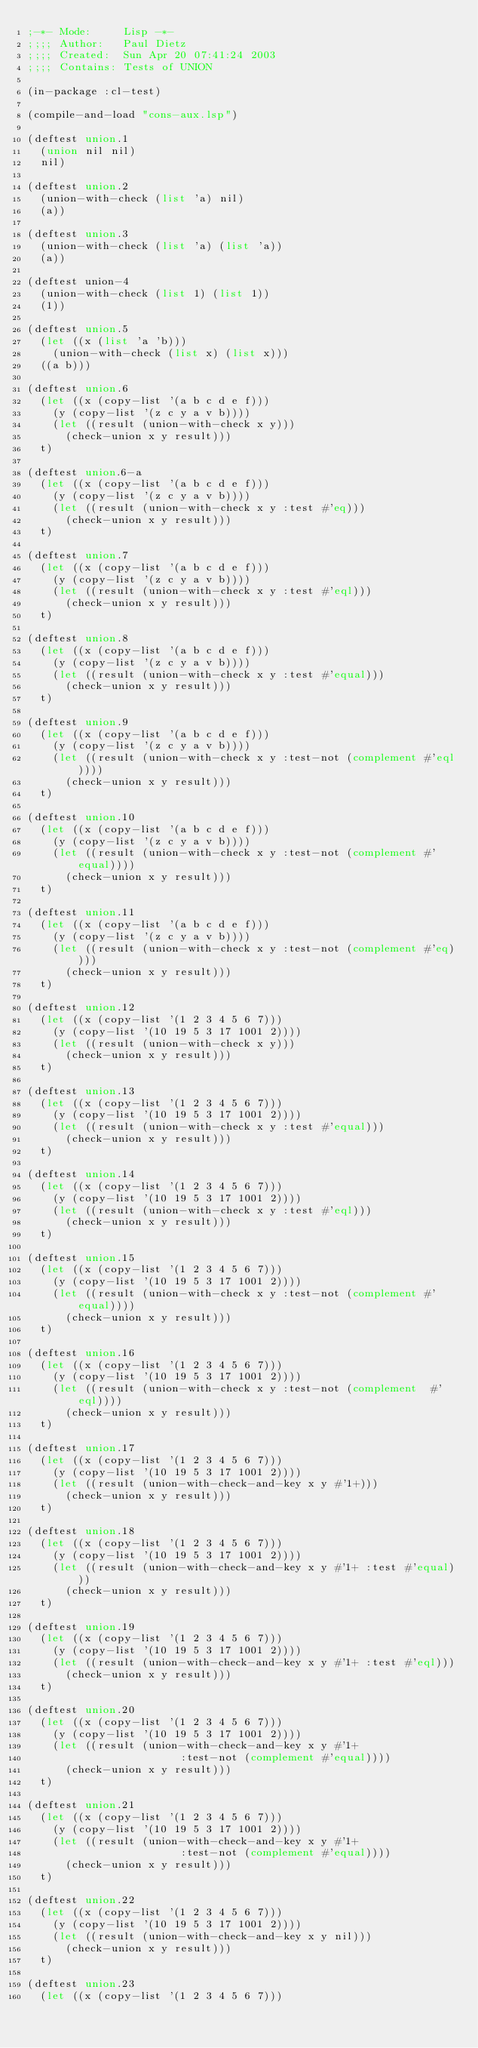Convert code to text. <code><loc_0><loc_0><loc_500><loc_500><_Lisp_>;-*- Mode:     Lisp -*-
;;;; Author:   Paul Dietz
;;;; Created:  Sun Apr 20 07:41:24 2003
;;;; Contains: Tests of UNION

(in-package :cl-test)

(compile-and-load "cons-aux.lsp")

(deftest union.1
  (union nil nil)
  nil)

(deftest union.2
  (union-with-check (list 'a) nil)
  (a))

(deftest union.3
  (union-with-check (list 'a) (list 'a))
  (a))

(deftest union-4
  (union-with-check (list 1) (list 1))
  (1))

(deftest union.5
  (let ((x (list 'a 'b)))
    (union-with-check (list x) (list x)))
  ((a b)))

(deftest union.6
  (let ((x (copy-list '(a b c d e f)))
	(y (copy-list '(z c y a v b))))
    (let ((result (union-with-check x y)))
      (check-union x y result)))
  t)

(deftest union.6-a
  (let ((x (copy-list '(a b c d e f)))
	(y (copy-list '(z c y a v b))))
    (let ((result (union-with-check x y :test #'eq)))
      (check-union x y result)))
  t)

(deftest union.7
  (let ((x (copy-list '(a b c d e f)))
	(y (copy-list '(z c y a v b))))
    (let ((result (union-with-check x y :test #'eql)))
      (check-union x y result)))
  t)

(deftest union.8
  (let ((x (copy-list '(a b c d e f)))
	(y (copy-list '(z c y a v b))))
    (let ((result (union-with-check x y :test #'equal)))
      (check-union x y result)))
  t)

(deftest union.9
  (let ((x (copy-list '(a b c d e f)))
	(y (copy-list '(z c y a v b))))
    (let ((result (union-with-check x y :test-not (complement #'eql))))
      (check-union x y result)))
  t)

(deftest union.10
  (let ((x (copy-list '(a b c d e f)))
	(y (copy-list '(z c y a v b))))
    (let ((result (union-with-check x y :test-not (complement #'equal))))
      (check-union x y result)))
  t)

(deftest union.11
  (let ((x (copy-list '(a b c d e f)))
	(y (copy-list '(z c y a v b))))
    (let ((result (union-with-check x y :test-not (complement #'eq))))
      (check-union x y result)))
  t)

(deftest union.12
  (let ((x (copy-list '(1 2 3 4 5 6 7)))
	(y (copy-list '(10 19 5 3 17 1001 2))))
    (let ((result (union-with-check x y)))
      (check-union x y result)))
  t)

(deftest union.13
  (let ((x (copy-list '(1 2 3 4 5 6 7)))
	(y (copy-list '(10 19 5 3 17 1001 2))))
    (let ((result (union-with-check x y :test #'equal)))
      (check-union x y result)))
  t)

(deftest union.14
  (let ((x (copy-list '(1 2 3 4 5 6 7)))
	(y (copy-list '(10 19 5 3 17 1001 2))))
    (let ((result (union-with-check x y :test #'eql)))
      (check-union x y result)))
  t)

(deftest union.15
  (let ((x (copy-list '(1 2 3 4 5 6 7)))
	(y (copy-list '(10 19 5 3 17 1001 2))))
    (let ((result (union-with-check x y :test-not (complement #'equal))))
      (check-union x y result)))
  t)

(deftest union.16
  (let ((x (copy-list '(1 2 3 4 5 6 7)))
	(y (copy-list '(10 19 5 3 17 1001 2))))
    (let ((result (union-with-check x y :test-not (complement  #'eql))))
      (check-union x y result)))
  t)

(deftest union.17
  (let ((x (copy-list '(1 2 3 4 5 6 7)))
	(y (copy-list '(10 19 5 3 17 1001 2))))
    (let ((result (union-with-check-and-key x y #'1+)))
      (check-union x y result)))
  t)

(deftest union.18
  (let ((x (copy-list '(1 2 3 4 5 6 7)))
	(y (copy-list '(10 19 5 3 17 1001 2))))
    (let ((result (union-with-check-and-key x y #'1+ :test #'equal)))
      (check-union x y result)))
  t)

(deftest union.19
  (let ((x (copy-list '(1 2 3 4 5 6 7)))
	(y (copy-list '(10 19 5 3 17 1001 2))))
    (let ((result (union-with-check-and-key x y #'1+ :test #'eql)))
      (check-union x y result)))
  t)

(deftest union.20
  (let ((x (copy-list '(1 2 3 4 5 6 7)))
	(y (copy-list '(10 19 5 3 17 1001 2))))
    (let ((result (union-with-check-and-key x y #'1+
					    :test-not (complement #'equal))))
      (check-union x y result)))
  t)

(deftest union.21
  (let ((x (copy-list '(1 2 3 4 5 6 7)))
	(y (copy-list '(10 19 5 3 17 1001 2))))
    (let ((result (union-with-check-and-key x y #'1+
					    :test-not (complement #'equal))))
      (check-union x y result)))
  t)

(deftest union.22
  (let ((x (copy-list '(1 2 3 4 5 6 7)))
	(y (copy-list '(10 19 5 3 17 1001 2))))
    (let ((result (union-with-check-and-key x y nil)))
      (check-union x y result)))
  t)

(deftest union.23
  (let ((x (copy-list '(1 2 3 4 5 6 7)))</code> 